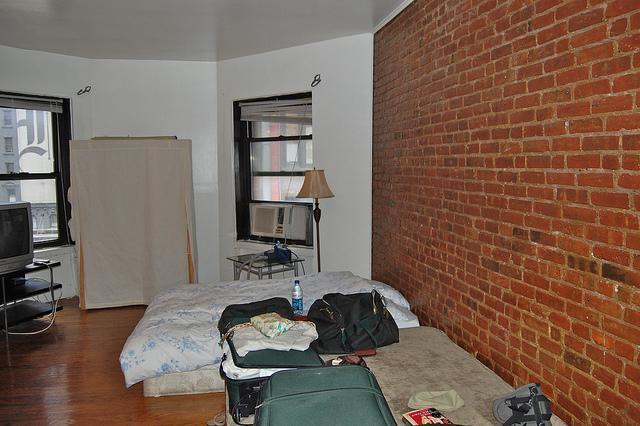How many lamps are in the room?
Give a very brief answer. 1. How many handbags can you see?
Give a very brief answer. 2. How many tvs can be seen?
Give a very brief answer. 1. How many beds are there?
Give a very brief answer. 1. How many suitcases are visible?
Give a very brief answer. 2. How many wheels does the bus have?
Give a very brief answer. 0. 